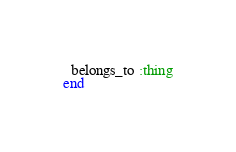Convert code to text. <code><loc_0><loc_0><loc_500><loc_500><_Ruby_>  belongs_to :thing
end
</code> 